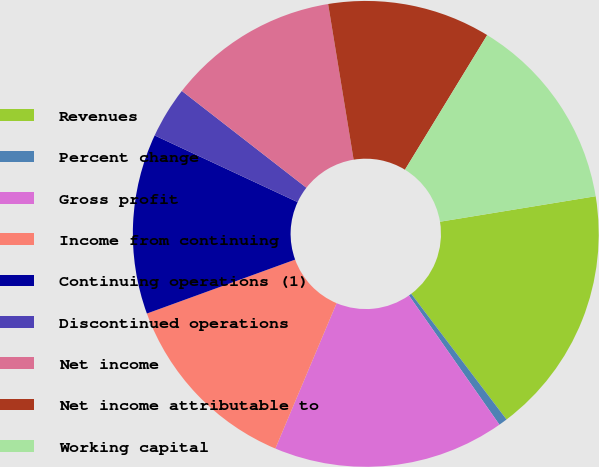Convert chart to OTSL. <chart><loc_0><loc_0><loc_500><loc_500><pie_chart><fcel>Revenues<fcel>Percent change<fcel>Gross profit<fcel>Income from continuing<fcel>Continuing operations (1)<fcel>Discontinued operations<fcel>Net income<fcel>Net income attributable to<fcel>Working capital<nl><fcel>17.26%<fcel>0.6%<fcel>16.07%<fcel>13.1%<fcel>12.5%<fcel>3.57%<fcel>11.9%<fcel>11.31%<fcel>13.69%<nl></chart> 